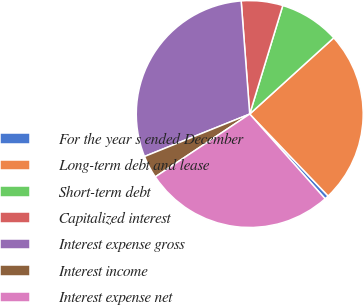<chart> <loc_0><loc_0><loc_500><loc_500><pie_chart><fcel>For the year s ended December<fcel>Long-term debt and lease<fcel>Short-term debt<fcel>Capitalized interest<fcel>Interest expense gross<fcel>Interest income<fcel>Interest expense net<nl><fcel>0.58%<fcel>24.57%<fcel>8.57%<fcel>5.91%<fcel>29.9%<fcel>3.24%<fcel>27.23%<nl></chart> 